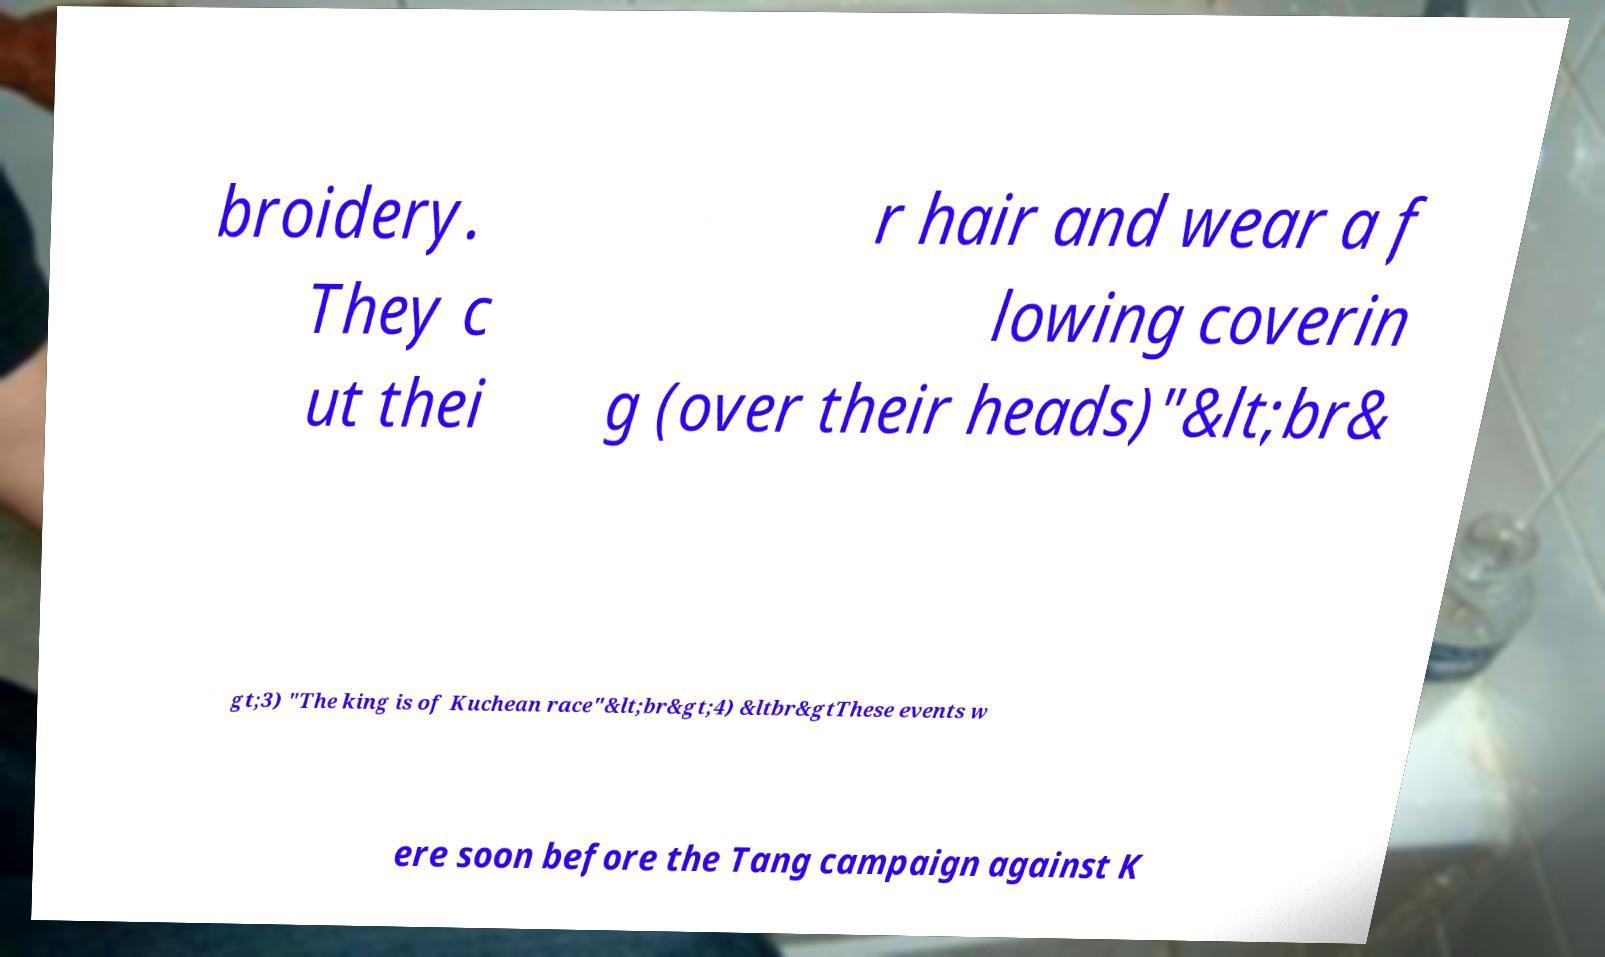Could you assist in decoding the text presented in this image and type it out clearly? broidery. They c ut thei r hair and wear a f lowing coverin g (over their heads)"&lt;br& gt;3) "The king is of Kuchean race"&lt;br&gt;4) &ltbr&gtThese events w ere soon before the Tang campaign against K 